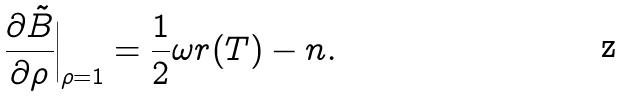Convert formula to latex. <formula><loc_0><loc_0><loc_500><loc_500>\frac { \partial \tilde { B } } { \partial \rho } \Big | _ { \rho = 1 } = \frac { 1 } { 2 } \omega r ( T ) - n .</formula> 